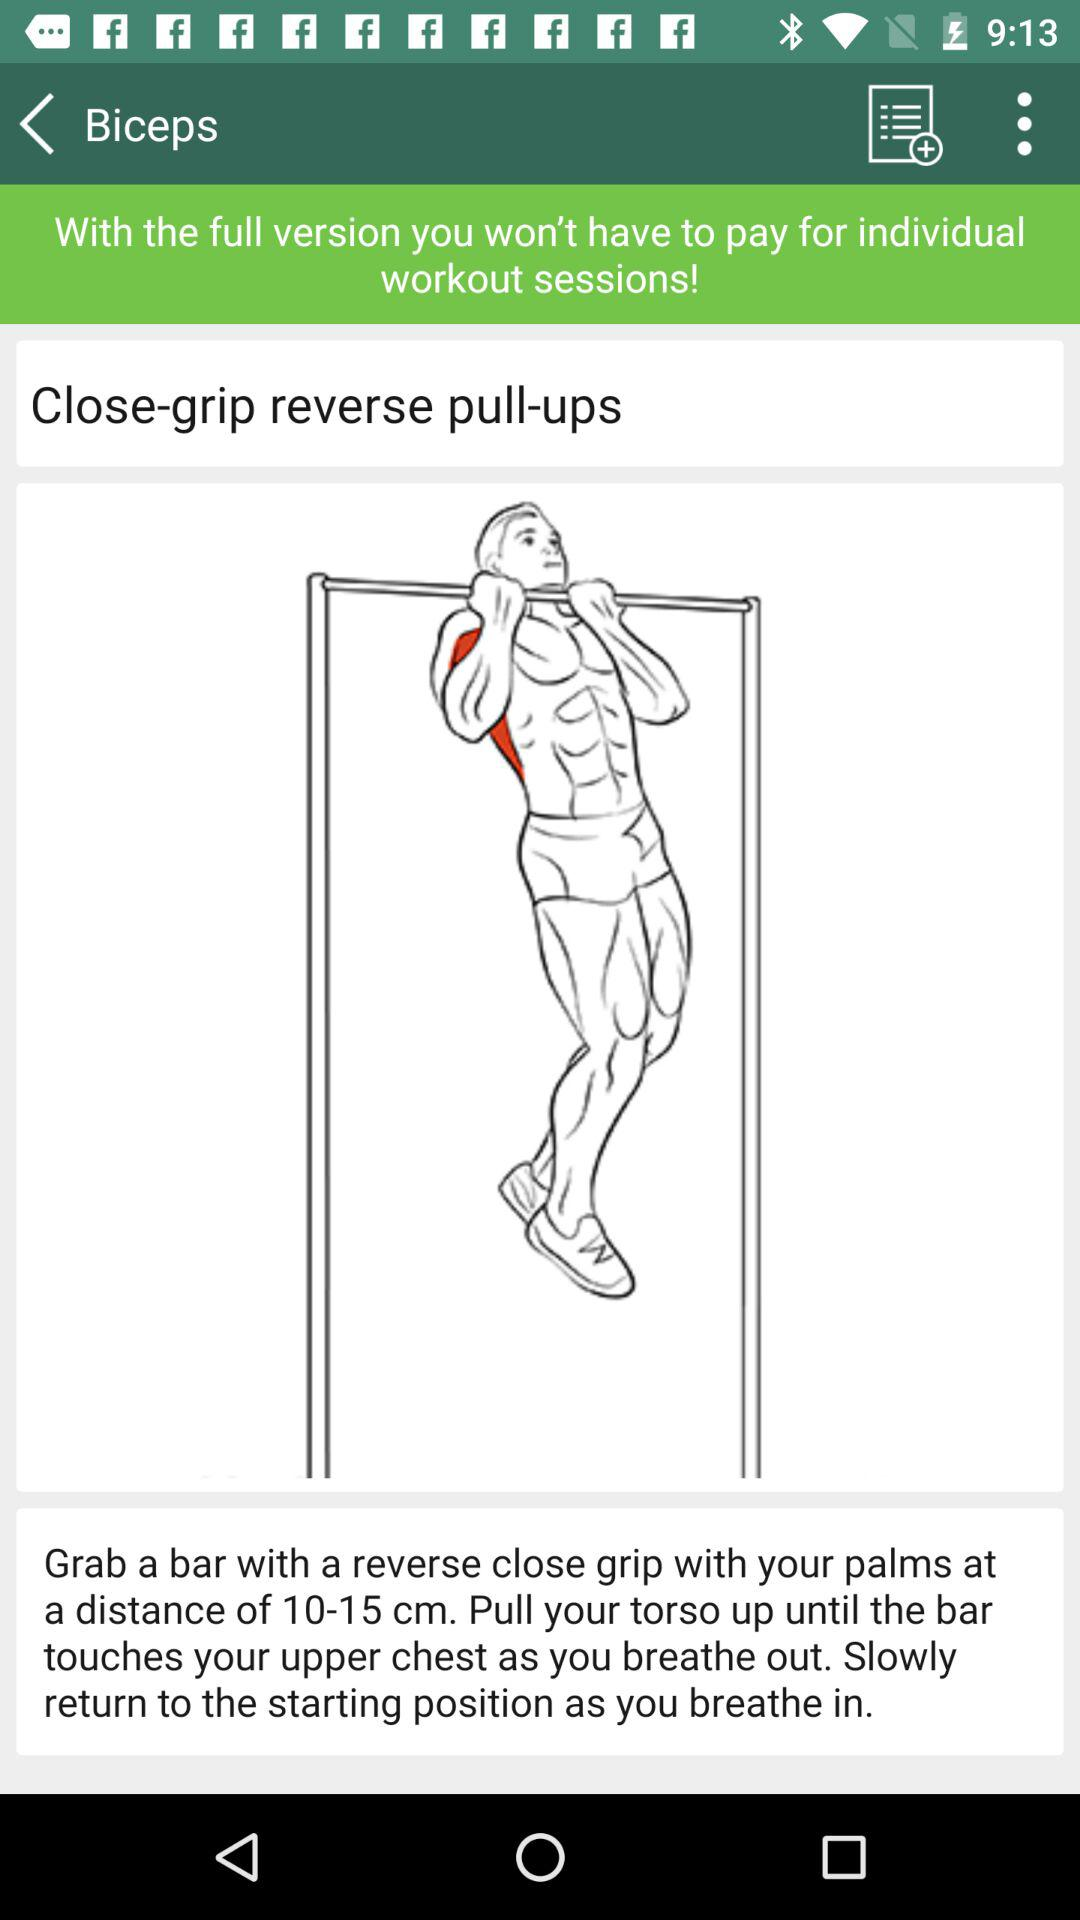What is the exercise name? The exercise name is close-grip reverse pull-ups. 